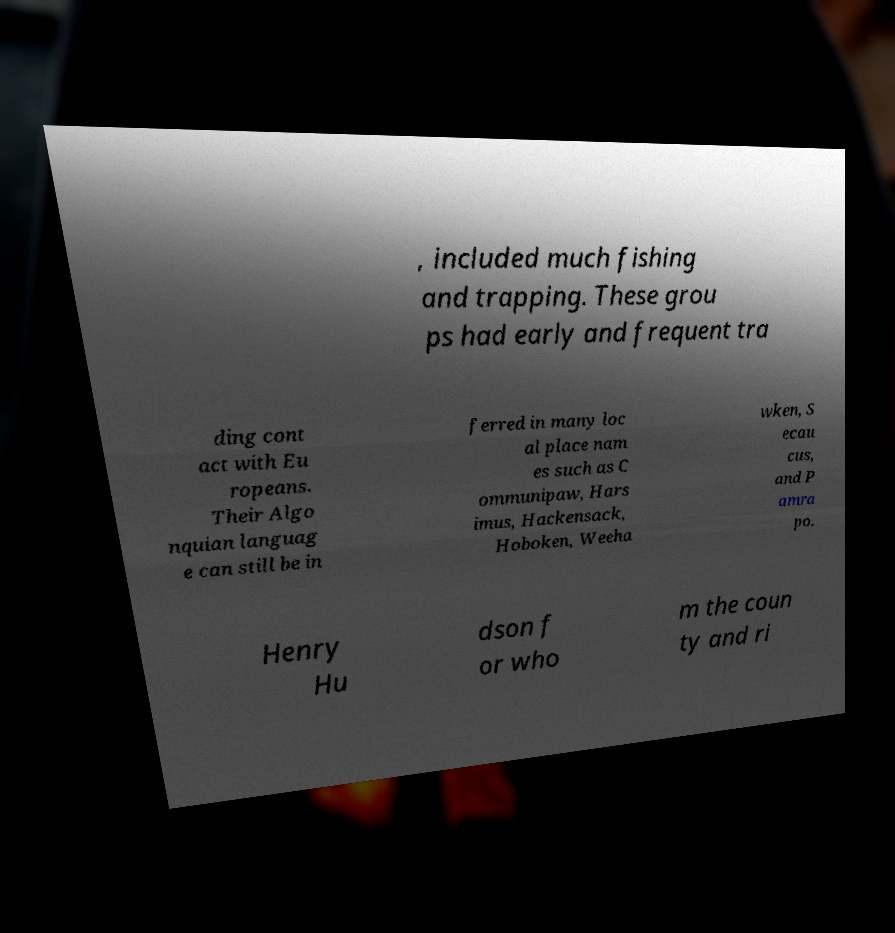I need the written content from this picture converted into text. Can you do that? , included much fishing and trapping. These grou ps had early and frequent tra ding cont act with Eu ropeans. Their Algo nquian languag e can still be in ferred in many loc al place nam es such as C ommunipaw, Hars imus, Hackensack, Hoboken, Weeha wken, S ecau cus, and P amra po. Henry Hu dson f or who m the coun ty and ri 